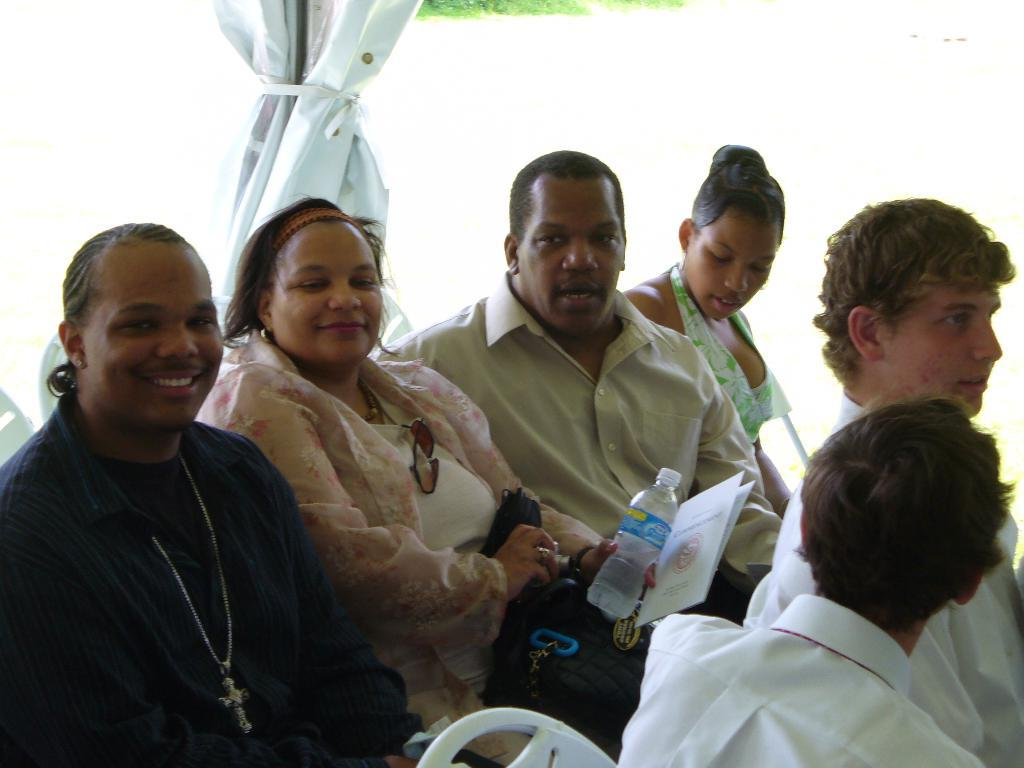What can be seen in the background of the image? There is an object in the background of the image. What are the people in the image doing? There are people sitting on chairs in the image. What is the woman holding in the image? A woman is holding a bottle in the image. What type of vehicle is visible in the image? A car is visible in the image. What else can be seen in the image besides the people and the car? There is a bag in the image. How is the woman feeling in the image? The woman is smiling in the image. What type of scarf is the woman wearing in the image? There is no scarf present in the image; the woman is holding a bottle. How many boys are visible in the image? There are no boys visible in the image; the people in the image are not specified as boys. 